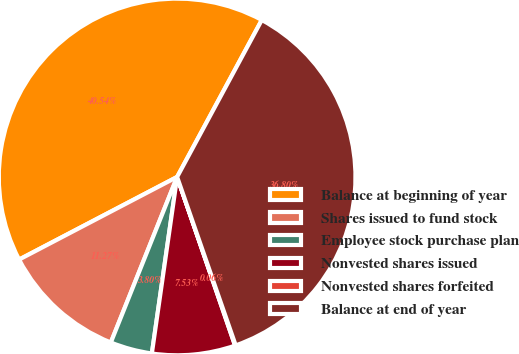Convert chart. <chart><loc_0><loc_0><loc_500><loc_500><pie_chart><fcel>Balance at beginning of year<fcel>Shares issued to fund stock<fcel>Employee stock purchase plan<fcel>Nonvested shares issued<fcel>Nonvested shares forfeited<fcel>Balance at end of year<nl><fcel>40.54%<fcel>11.27%<fcel>3.8%<fcel>7.53%<fcel>0.06%<fcel>36.8%<nl></chart> 